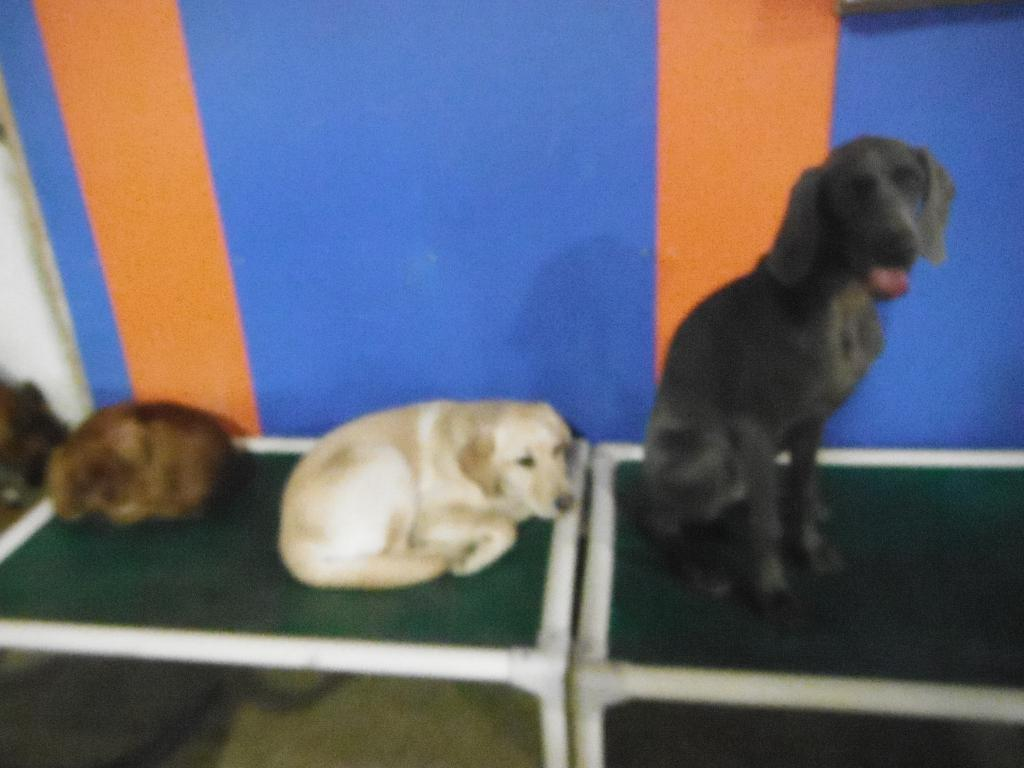What type of animals are in the image? There are dogs in the image. What can be seen in the background of the image? There is a wall in the background of the image. What is the opinion of the dogs about the voyage in the image? There is no voyage or opinion present in the image, as it only features dogs and a wall in the background. 